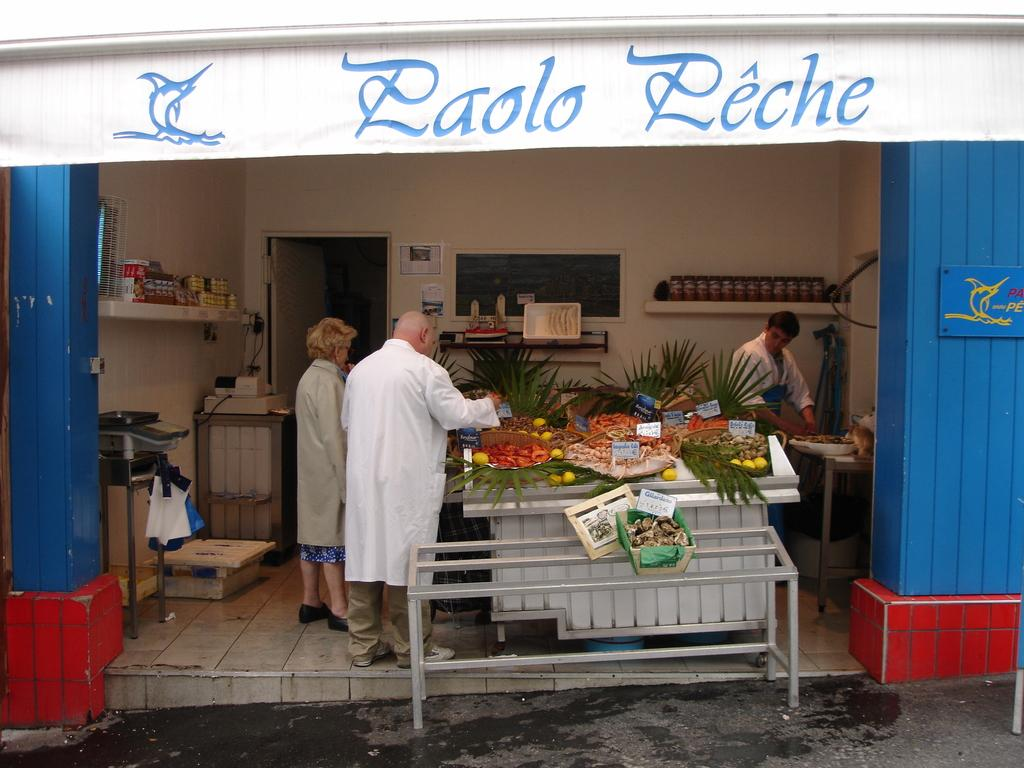What can be seen in the image? There are people standing in the image. What is present in the image besides the people? There is a table in the image. What is on the table? There are vegetables on the table. What type of apple is being used to expand the jelly in the image? There is no apple or jelly present in the image; it features people standing near a table with vegetables on it. 